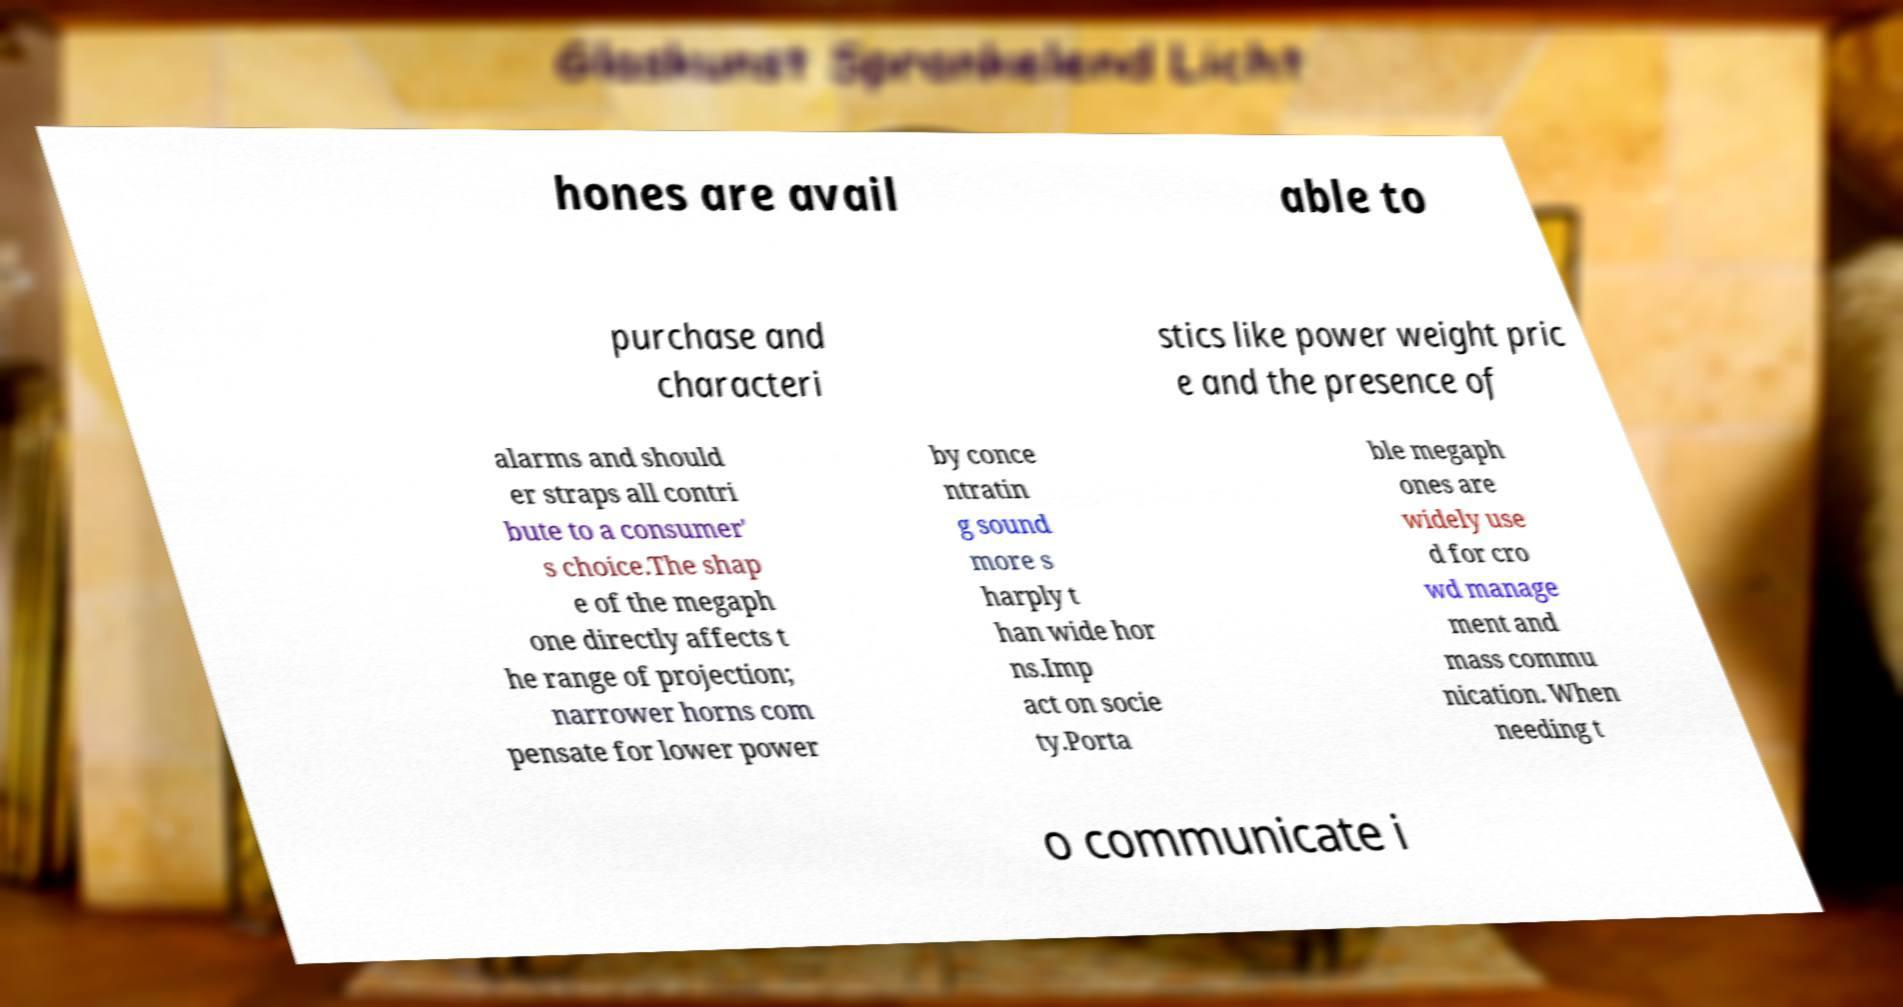Could you extract and type out the text from this image? hones are avail able to purchase and characteri stics like power weight pric e and the presence of alarms and should er straps all contri bute to a consumer' s choice.The shap e of the megaph one directly affects t he range of projection; narrower horns com pensate for lower power by conce ntratin g sound more s harply t han wide hor ns.Imp act on socie ty.Porta ble megaph ones are widely use d for cro wd manage ment and mass commu nication. When needing t o communicate i 